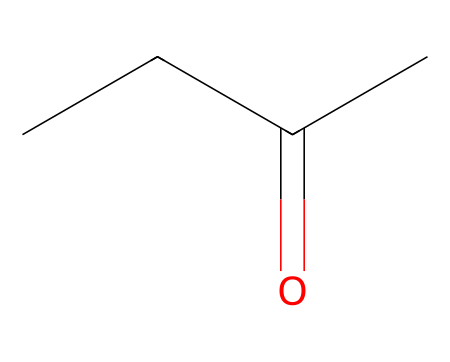How many carbon atoms are present in methyl ethyl ketone? The SMILES representation indicates three carbon atoms in the chain (CCC) and one carbon in the carbonyl group (=O, C=O), totaling four carbon atoms.
Answer: four What is the functional group present in this chemical? The structure features a carbonyl group indicated by the "C(=O)" part of the SMILES, which characterizes ketones.
Answer: carbonyl How many hydrogen atoms are in methyl ethyl ketone? From the structure, we see that each of the three carbon atoms contributes to the hydrogens, resulting in a total of eight hydrogen atoms connected to the carbon atoms after considering bonding with the carbonyl.
Answer: eight What type of chemical is methyl ethyl ketone? The presence of the carbonyl group attached to two carbon chains classifies methyl ethyl ketone as a ketone.
Answer: ketone What is the molecular formula of methyl ethyl ketone? By analyzing the atom counts, we have four carbon atoms, eight hydrogen atoms, and one oxygen atom, leading to the formula C4H8O.
Answer: C4H8O 